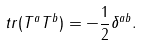<formula> <loc_0><loc_0><loc_500><loc_500>t r ( T ^ { a } T ^ { b } ) = - \frac { 1 } { 2 } \delta ^ { a b } .</formula> 